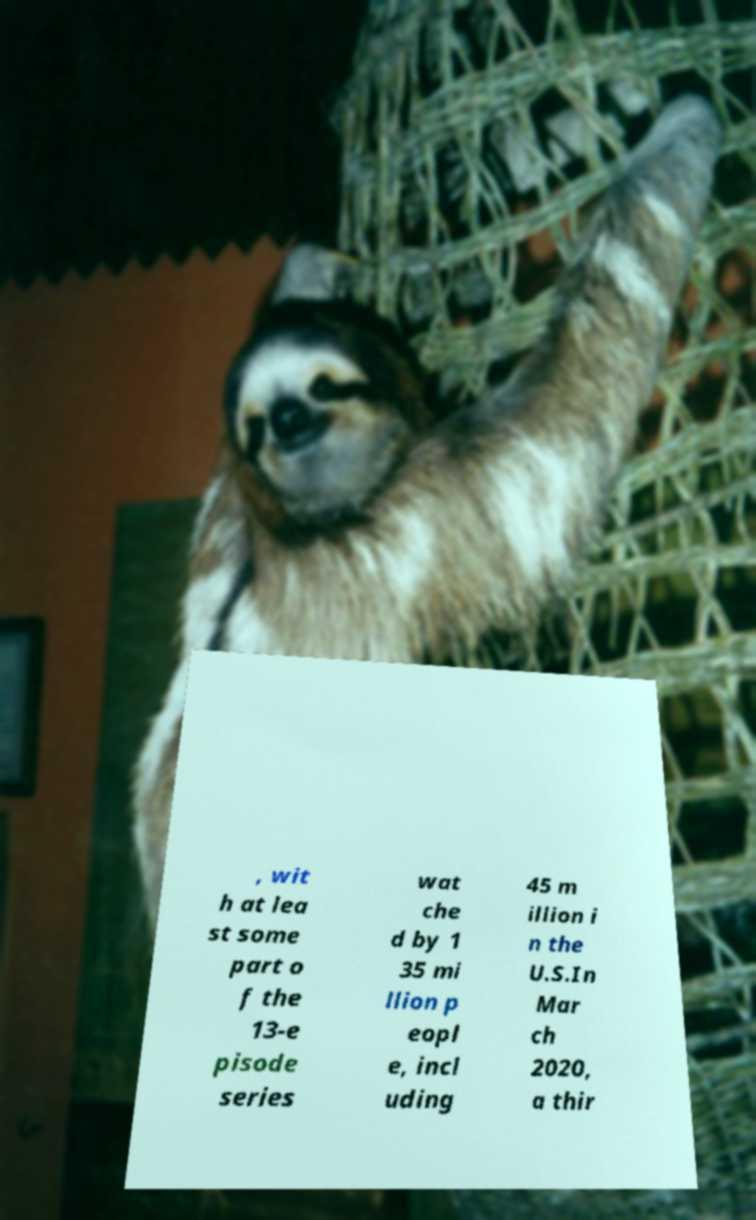What messages or text are displayed in this image? I need them in a readable, typed format. , wit h at lea st some part o f the 13-e pisode series wat che d by 1 35 mi llion p eopl e, incl uding 45 m illion i n the U.S.In Mar ch 2020, a thir 